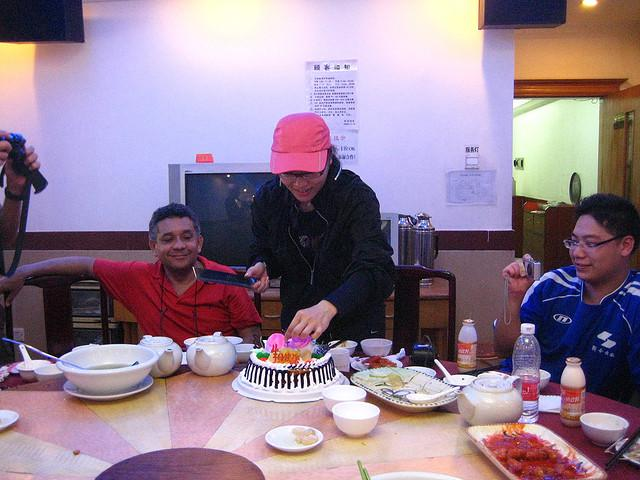What is the woman doing with the knife? Please explain your reasoning. cutting. She has a sharp utensil in her hand that she is going to use to slice the cake. 